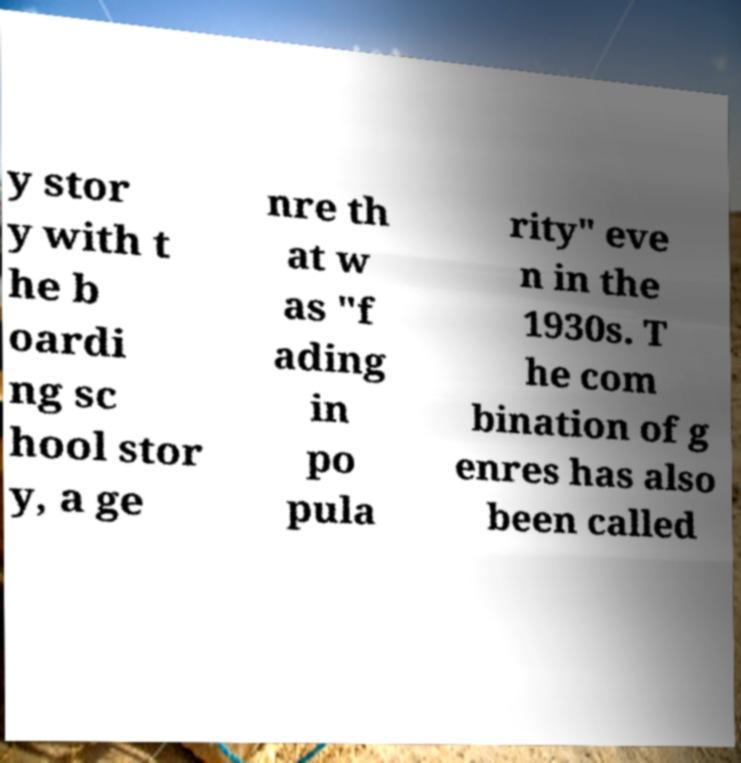What messages or text are displayed in this image? I need them in a readable, typed format. y stor y with t he b oardi ng sc hool stor y, a ge nre th at w as "f ading in po pula rity" eve n in the 1930s. T he com bination of g enres has also been called 